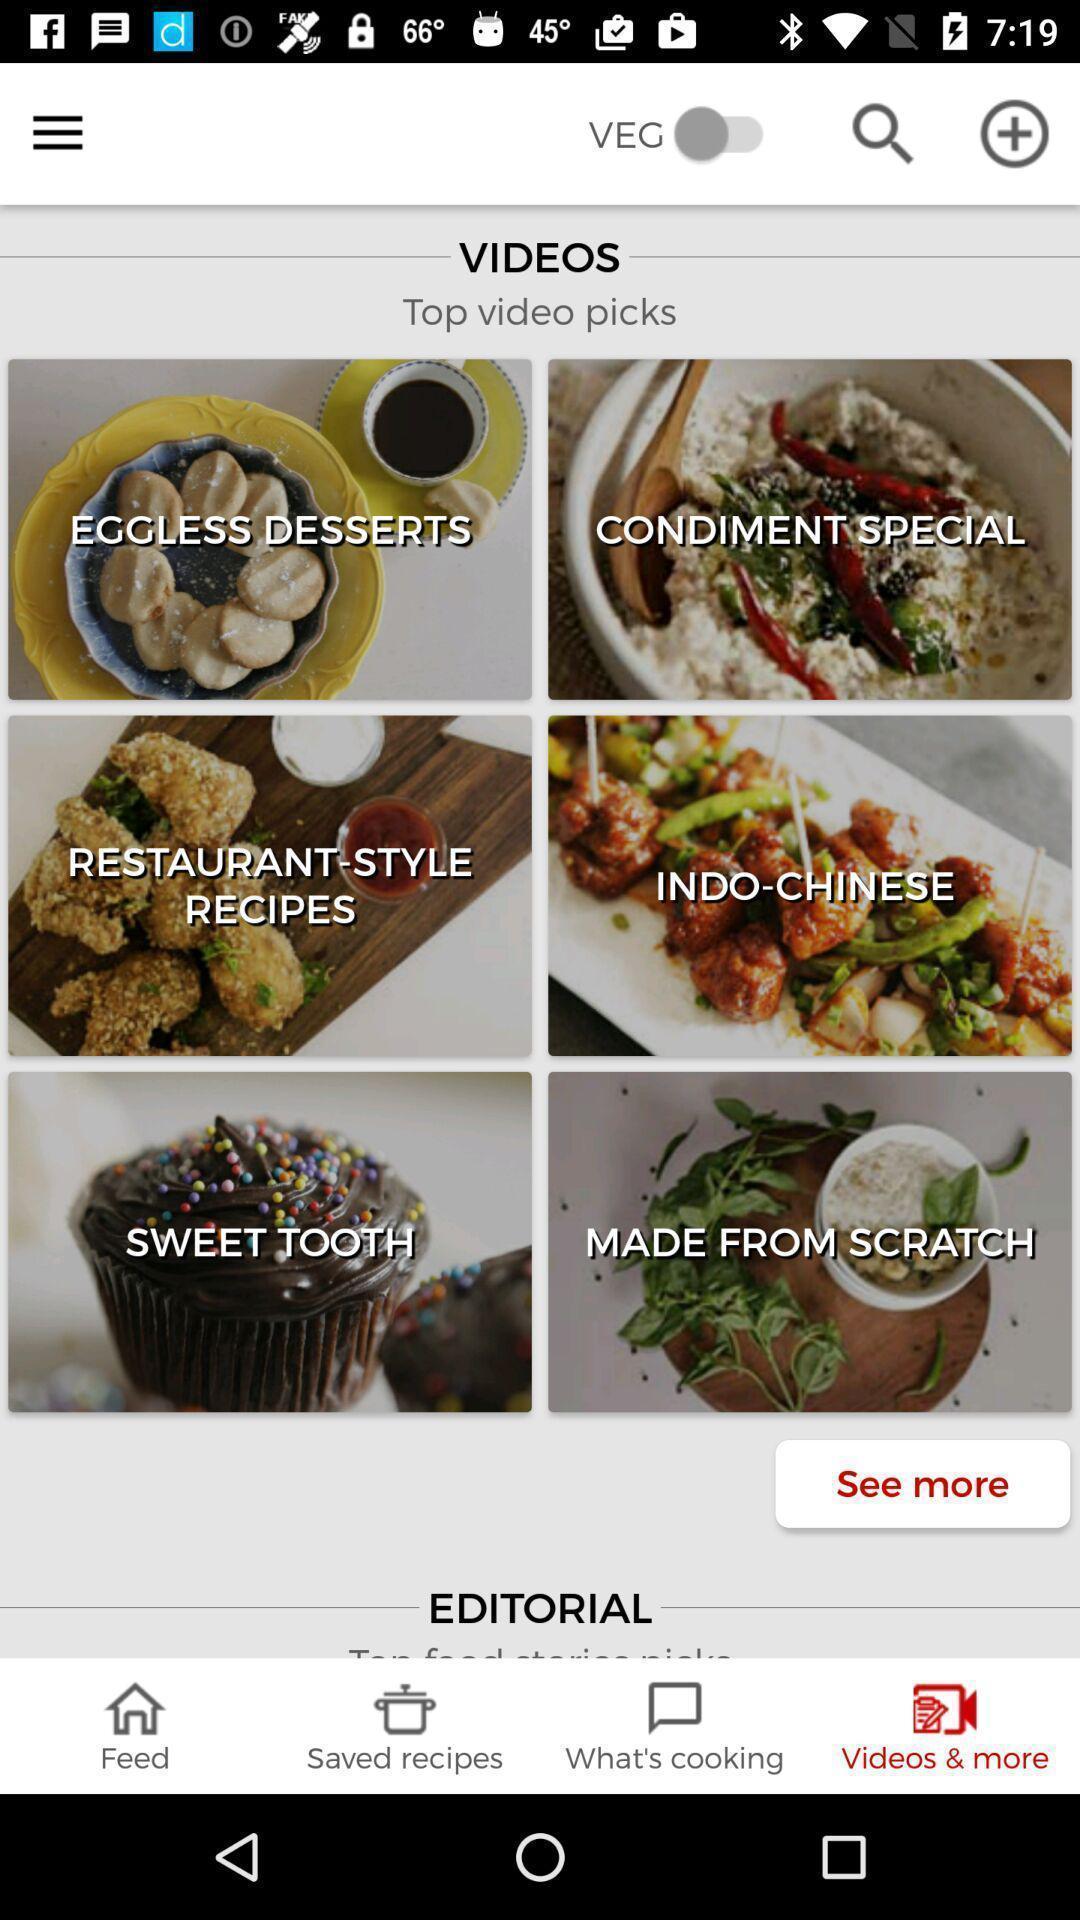What is the overall content of this screenshot? Screen displaying the various dishes. 